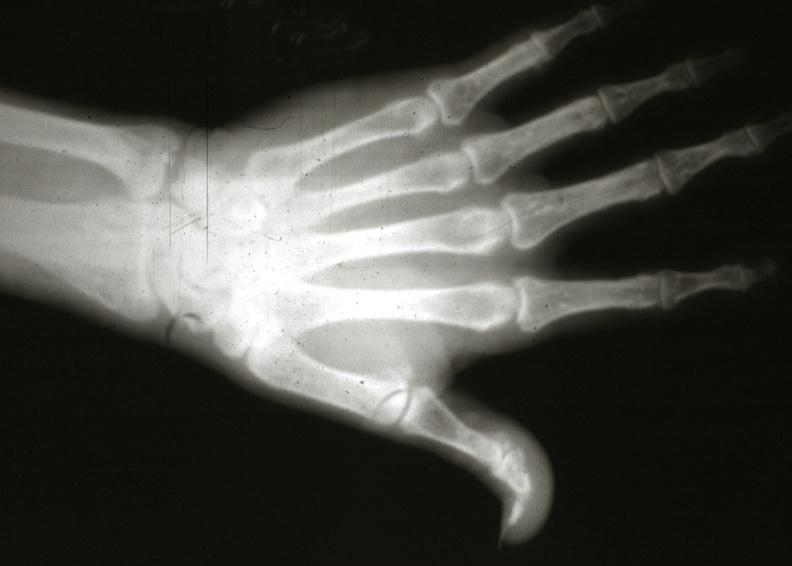does this image show x-ray hand?
Answer the question using a single word or phrase. Yes 